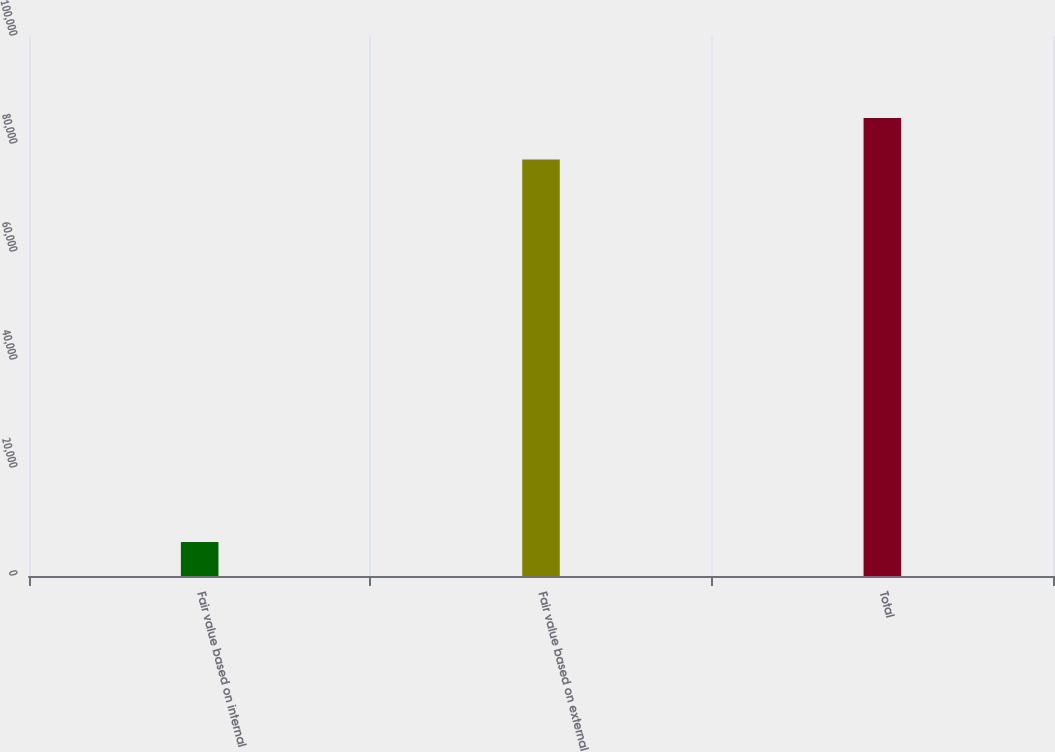<chart> <loc_0><loc_0><loc_500><loc_500><bar_chart><fcel>Fair value based on internal<fcel>Fair value based on external<fcel>Total<nl><fcel>6277<fcel>77113<fcel>84824.3<nl></chart> 